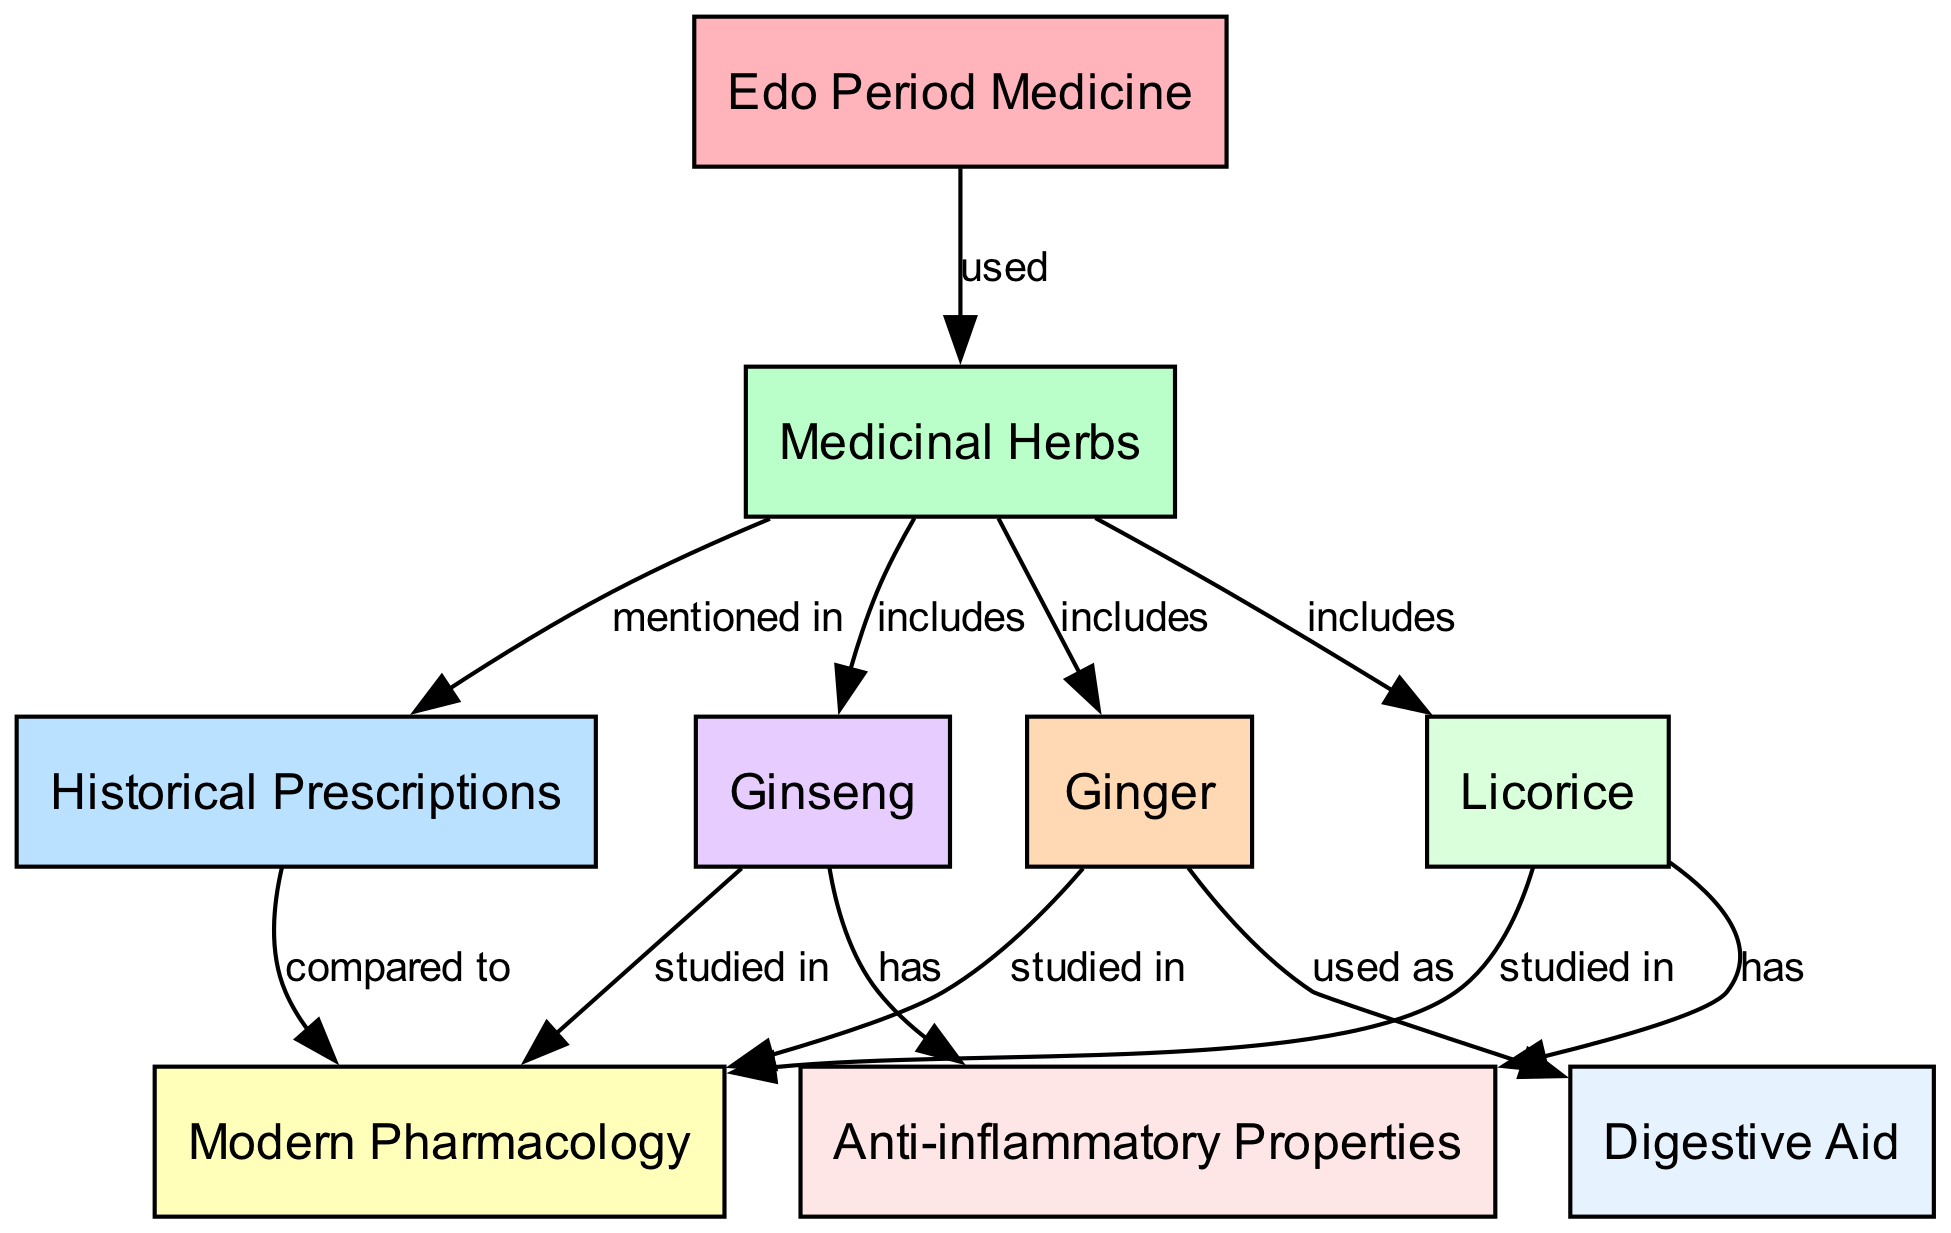What is the main focus of the diagram? The diagram illustrates the relationship between Edo Period Medicine and Medicinal Herbs, specifically comparing historical prescriptions with modern pharmacology. The central theme is the use of medicinal herbs during the Edo period and their relevance in current pharmacological studies.
Answer: Role of Medicinal Herbs in Edo Period Medicine How many medicinal herbs are mentioned in the diagram? The diagram includes three specific medicinal herbs: Ginseng, Ginger, and Licorice. Each herb is listed as a node that is linked to the larger category of medicinal herbs. Counting these nodes gives us a total of three.
Answer: Three Which herb is associated with anti-inflammatory properties? The diagram shows that both Ginseng and Licorice have been linked to anti-inflammatory properties. This is specifically noted in the edges that connect these herbs to the 'Anti-inflammatory Properties' node.
Answer: Ginseng and Licorice What does Ginger serve as according to the diagram? The diagram notes that Ginger is used as a digestive aid, indicated by the edge connecting the Ginger node to the Digestive Aid node. This direct connection specifies its function within the context of medicinal herbs.
Answer: Digestive Aid Which category do Historical Prescriptions relate to? Historical prescriptions are related to the category of medicinal herbs, as shown in the diagram where there is an edge connecting Historical Prescriptions to Medicinal Herbs. This indicates that historical documents mentioned the use of these herbs.
Answer: Medicinal Herbs Which herb does the diagram suggest is studied in modern pharmacology? The diagram indicates that Ginseng, Ginger, and Licorice are all studied in modern pharmacology based on their connections to the Modern Pharmacology node. Therefore, multiple herbs fall under this category.
Answer: Ginseng, Ginger, Licorice How are Edo Period Medicine and Medicinal Herbs connected? The connection between Edo Period Medicine and Medicinal Herbs is shown through an edge indicating that medicinal herbs were used in Edo period medicine. This direct link clarifies the importance of herbs in this historical context.
Answer: Used Which herb is associated with both anti-inflammatory properties and modern pharmacology? The diagram shows Ginseng and Licorice are both linked to both anti-inflammatory properties and modern pharmacology, reflecting their studied relevance in current medicine.
Answer: Ginseng and Licorice 